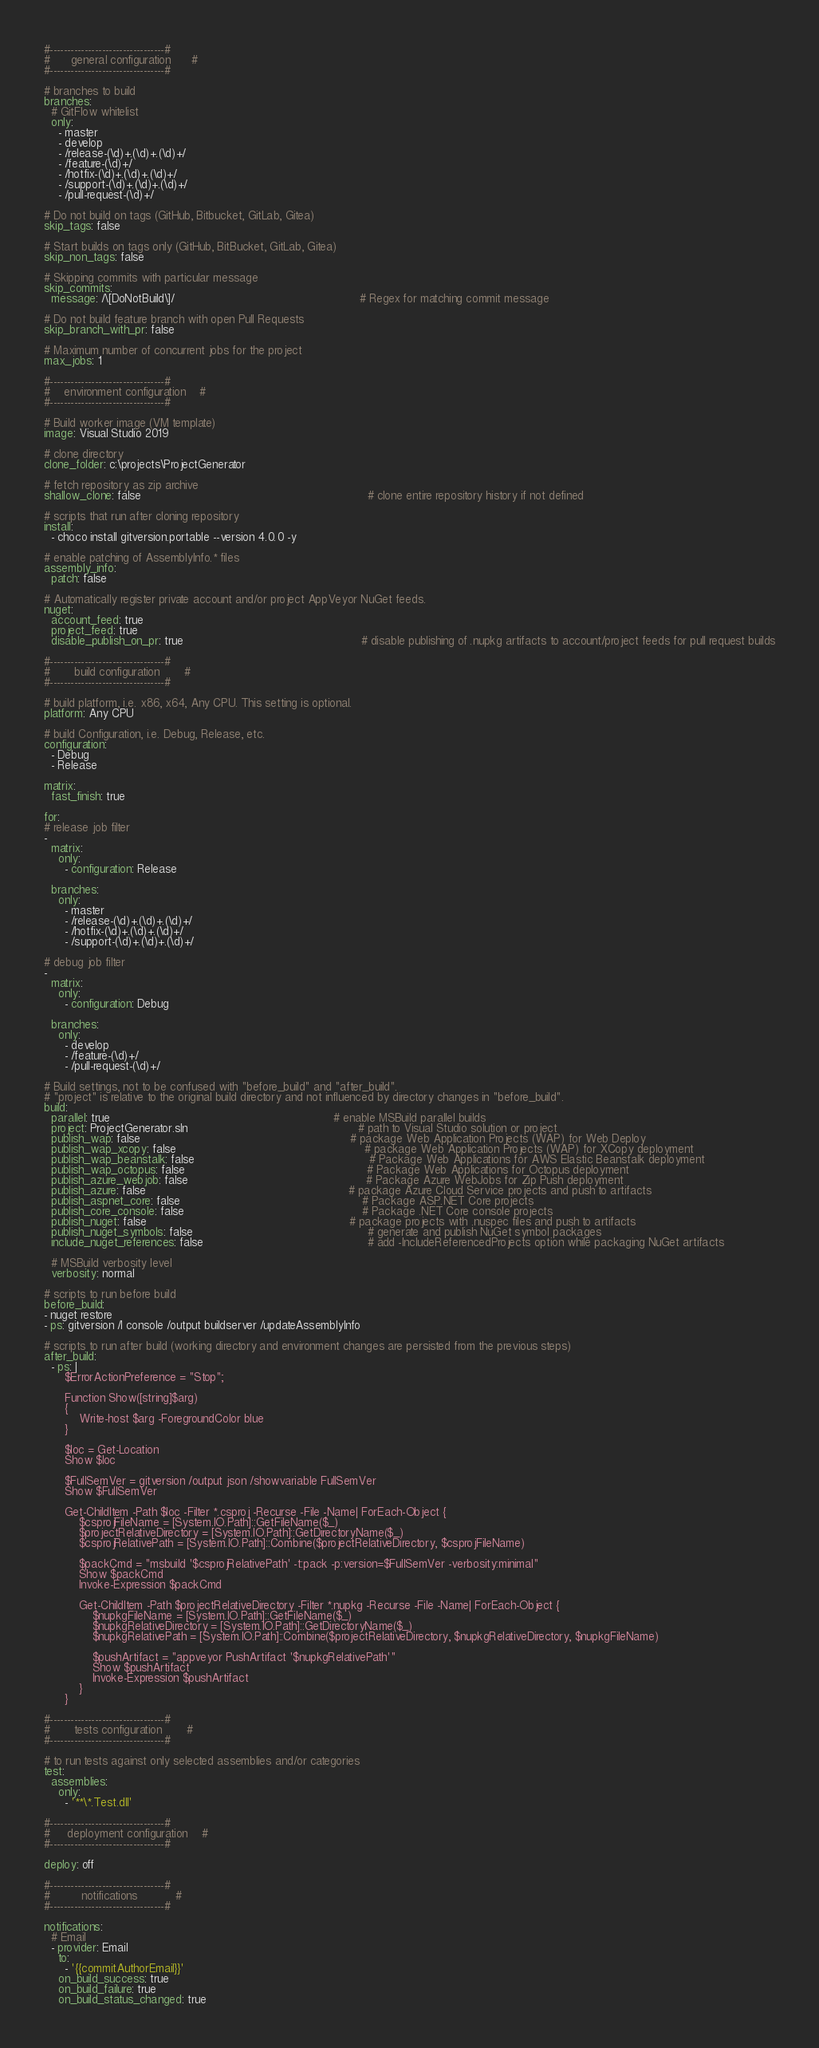<code> <loc_0><loc_0><loc_500><loc_500><_YAML_>#---------------------------------#
#      general configuration      #
#---------------------------------#

# branches to build
branches:
  # GitFlow whitelist
  only:
    - master
    - develop
    - /release-(\d)+.(\d)+.(\d)+/
    - /feature-(\d)+/
    - /hotfix-(\d)+.(\d)+.(\d)+/
    - /support-(\d)+.(\d)+.(\d)+/
    - /pull-request-(\d)+/

# Do not build on tags (GitHub, Bitbucket, GitLab, Gitea)
skip_tags: false

# Start builds on tags only (GitHub, BitBucket, GitLab, Gitea)
skip_non_tags: false

# Skipping commits with particular message
skip_commits:
  message: /\[DoNotBuild\]/                                                     # Regex for matching commit message

# Do not build feature branch with open Pull Requests
skip_branch_with_pr: false

# Maximum number of concurrent jobs for the project
max_jobs: 1

#---------------------------------#
#    environment configuration    #
#---------------------------------#

# Build worker image (VM template)
image: Visual Studio 2019

# clone directory
clone_folder: c:\projects\ProjectGenerator

# fetch repository as zip archive
shallow_clone: false                                                                 # clone entire repository history if not defined

# scripts that run after cloning repository
install:
  - choco install gitversion.portable --version 4.0.0 -y

# enable patching of AssemblyInfo.* files
assembly_info:
  patch: false

# Automatically register private account and/or project AppVeyor NuGet feeds.
nuget:
  account_feed: true
  project_feed: true
  disable_publish_on_pr: true                                                   # disable publishing of .nupkg artifacts to account/project feeds for pull request builds

#---------------------------------#
#       build configuration       #
#---------------------------------#

# build platform, i.e. x86, x64, Any CPU. This setting is optional.
platform: Any CPU

# build Configuration, i.e. Debug, Release, etc.
configuration:
  - Debug
  - Release

matrix:
  fast_finish: true

for:
# release job filter
-
  matrix:
    only:
      - configuration: Release

  branches:
    only:
      - master
      - /release-(\d)+.(\d)+.(\d)+/
      - /hotfix-(\d)+.(\d)+.(\d)+/
      - /support-(\d)+.(\d)+.(\d)+/

# debug job filter
-
  matrix:
    only:
      - configuration: Debug

  branches:
    only:
      - develop
      - /feature-(\d)+/
      - /pull-request-(\d)+/

# Build settings, not to be confused with "before_build" and "after_build".
# "project" is relative to the original build directory and not influenced by directory changes in "before_build".
build:
  parallel: true                                                                # enable MSBuild parallel builds
  project: ProjectGenerator.sln                                                 # path to Visual Studio solution or project
  publish_wap: false                                                            # package Web Application Projects (WAP) for Web Deploy
  publish_wap_xcopy: false                                                      # package Web Application Projects (WAP) for XCopy deployment
  publish_wap_beanstalk: false                                                  # Package Web Applications for AWS Elastic Beanstalk deployment
  publish_wap_octopus: false                                                    # Package Web Applications for Octopus deployment
  publish_azure_webjob: false                                                   # Package Azure WebJobs for Zip Push deployment
  publish_azure: false                                                          # package Azure Cloud Service projects and push to artifacts
  publish_aspnet_core: false                                                    # Package ASP.NET Core projects
  publish_core_console: false                                                   # Package .NET Core console projects
  publish_nuget: false                                                          # package projects with .nuspec files and push to artifacts
  publish_nuget_symbols: false                                                  # generate and publish NuGet symbol packages
  include_nuget_references: false                                               # add -IncludeReferencedProjects option while packaging NuGet artifacts

  # MSBuild verbosity level
  verbosity: normal

# scripts to run before build
before_build:
- nuget restore
- ps: gitversion /l console /output buildserver /updateAssemblyInfo

# scripts to run after build (working directory and environment changes are persisted from the previous steps)
after_build:
  - ps: |
      $ErrorActionPreference = "Stop";

      Function Show([string]$arg)
      {
          Write-host $arg -ForegroundColor blue
      }

      $loc = Get-Location
      Show $loc

      $FullSemVer = gitversion /output json /showvariable FullSemVer
      Show $FullSemVer

      Get-ChildItem -Path $loc -Filter *.csproj -Recurse -File -Name| ForEach-Object {
          $csprojFileName = [System.IO.Path]::GetFileName($_)
          $projectRelativeDirectory = [System.IO.Path]::GetDirectoryName($_)
          $csprojRelativePath = [System.IO.Path]::Combine($projectRelativeDirectory, $csprojFileName)

          $packCmd = "msbuild '$csprojRelativePath' -t:pack -p:version=$FullSemVer -verbosity:minimal"
          Show $packCmd
          Invoke-Expression $packCmd

          Get-ChildItem -Path $projectRelativeDirectory -Filter *.nupkg -Recurse -File -Name| ForEach-Object {
              $nupkgFileName = [System.IO.Path]::GetFileName($_)
              $nupkgRelativeDirectory = [System.IO.Path]::GetDirectoryName($_)
              $nupkgRelativePath = [System.IO.Path]::Combine($projectRelativeDirectory, $nupkgRelativeDirectory, $nupkgFileName)

              $pushArtifact = "appveyor PushArtifact '$nupkgRelativePath'"
              Show $pushArtifact
              Invoke-Expression $pushArtifact
          }
      }

#---------------------------------#
#       tests configuration       #
#---------------------------------#

# to run tests against only selected assemblies and/or categories
test:
  assemblies:
    only:
      - '**\*.Test.dll'

#---------------------------------#
#     deployment configuration    #
#---------------------------------#

deploy: off

#---------------------------------#
#         notifications           #
#---------------------------------#

notifications:
  # Email
  - provider: Email
    to:
      - '{{commitAuthorEmail}}'
    on_build_success: true
    on_build_failure: true
    on_build_status_changed: true
</code> 